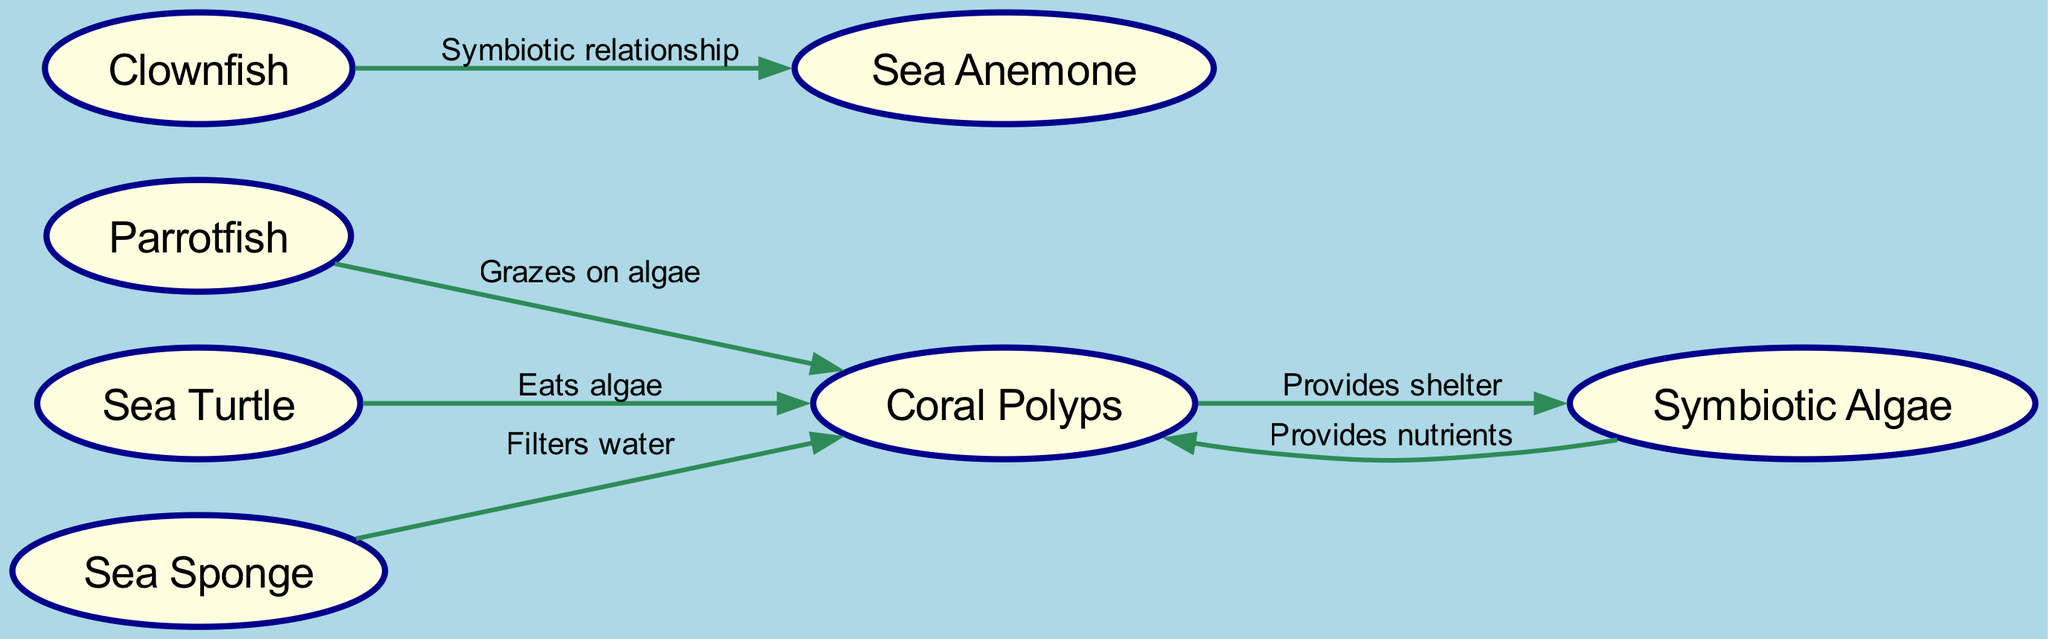What is the total number of nodes in the diagram? The diagram lists 7 distinct nodes representing different species and components of the coral reef ecosystem: Coral Polyps, Symbiotic Algae, Parrotfish, Clownfish, Sea Anemone, Sea Turtle, and Sea Sponge. Thus, the total number is 7.
Answer: 7 Which species provides nutrients to coral? The flow of the diagram indicates that Symbiotic Algae is connected to Coral Polyps with the label "Provides nutrients," denoting that algae are responsible for delivering nutrients to corals.
Answer: Symbiotic Algae How many edges are there in total in the diagram? Examining the diagram, there are 6 directed edges representing interactions between the various species. These connections detail the relationships in the ecosystem.
Answer: 6 Which species grazes on algae? The diagram shows a directed edge from Parrotfish to Coral with the label "Grazes on algae," indicating that the parrotfish consumes algae as part of its diet.
Answer: Parrotfish What is the relationship between Clownfish and Sea Anemone? The edge connecting Clownfish and Sea Anemone is labeled "Symbiotic relationship," which illustrates the mutualistic relationship that exists between these two species.
Answer: Symbiotic relationship Which marine species plays a role in filtering water? The connection between Sea Sponge and Coral is labeled "Filters water," highlighting that the sea sponge helps in purifying the water, benefiting coral growth.
Answer: Sea Sponge What do Sea Turtles eat according to the diagram? The diagram indicates that the directed edge from Sea Turtle to Coral is labeled "Eats algae," revealing that sea turtles consume algae in the marine ecosystem.
Answer: Algae 